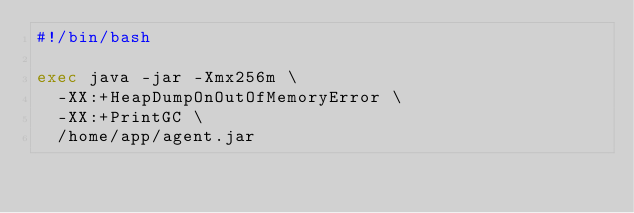<code> <loc_0><loc_0><loc_500><loc_500><_Bash_>#!/bin/bash

exec java -jar -Xmx256m \
  -XX:+HeapDumpOnOutOfMemoryError \
	-XX:+PrintGC \
  /home/app/agent.jar</code> 